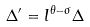Convert formula to latex. <formula><loc_0><loc_0><loc_500><loc_500>\Delta ^ { \prime } = l ^ { \theta - \sigma } \Delta</formula> 